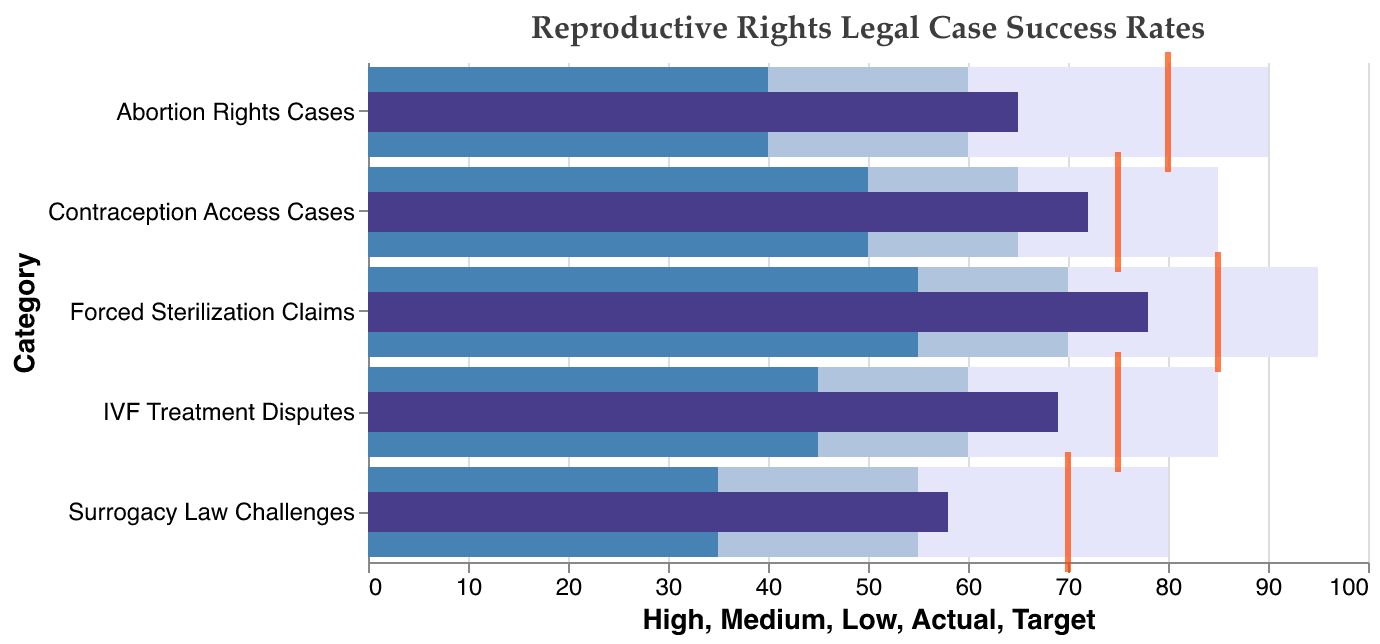What is the title of the chart? The title is displayed at the top of the chart and states the focus of the chart. The title reads "Reproductive Rights Legal Case Success Rates".
Answer: Reproductive Rights Legal Case Success Rates Which category has the highest actual success rate, and what is it? Looking at the darkest bars (representing actual success rates), "Forced Sterilization Claims" has the highest bar which indicates highest success rate. The actual success rate value is shown as 78.
Answer: Forced Sterilization Claims, 78 How does the actual success rate for Contraception Access Cases compare to its target? The target for Contraception Access Cases is indicated by a tick mark (orange) at 75, and the actual success rate is the dark bar at 72. Comparing these, the actual rate falls short by 3 points.
Answer: 3 points below target Which category has the largest gap between the actual success rate and its target, and what is the gap? To find the largest gap, compare the targets and actual figures for each category. "Abortion Rights Cases" has a target of 80 and an actual of 65, resulting in a difference of 15 points. Other gaps are smaller.
Answer: Abortion Rights Cases, 15 points On which end of the spectrum does the actual success rate for Surrogacy Law Challenges fall with respect to Low, Medium, and High ranges? For 'Surrogacy Law Challenges', the ranges are: Low (35), Medium (55), and High (80). The actual rate is 58 which falls into the Medium range.
Answer: Medium range What range is highlighted in blue for the Abortion Rights Cases? Observing the Abortion Rights Cases bar, the middle shaded section is in blue (Medium range). This range is from 60 to 90.
Answer: 60 to 90 How many categories have their actual success rate within the medium range defined for them? Review each category's actual rate and compare it with its respective Medium range: Abortion Rights Cases (65 falls into 60-90), Contraception Access Cases (72 in 65-85), Surrogacy Law Challenges (58 in 55-80), IVF Treatment Disputes (69 in 60-85), Forced Sterilization Claims (78 in 70-95). Each one falls into their Medium range. Hence, all 5 categories fit.
Answer: 5 categories Which category has the smallest difference between the low and high range, and what is the difference? To find the smallest difference, compute the ranges for each category. Abortion Rights Cases: 90-40=50, Contraception Access Cases: 85-50=35, Surrogacy Law Challenges: 80-35=45, IVF Treatment Disputes: 85-45=40, Forced Sterilization Claims: 95-55=40. Contraception Access Cases has the smallest difference, 35.
Answer: Contraception Access Cases, 35 